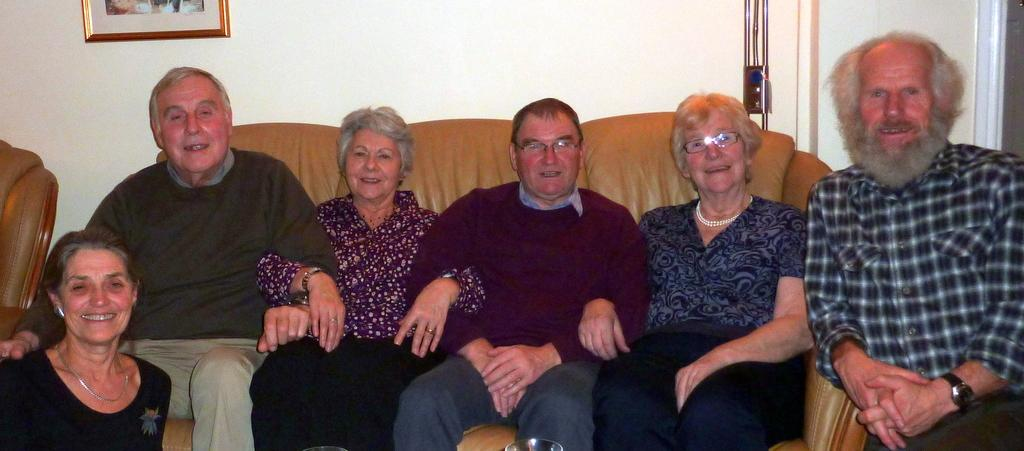Who is present in the image? There are old women and men in the image. What are they doing in the image? They are sitting on a sofa. What is behind them in the image? There is a wall behind them. What can be seen on the wall in the image? There is a photograph on the left side of the wall. What architectural feature is present on the left side of the wall? There is a door on the left side of the wall. What sound does the pig make in the image? There is no pig present in the image, so it is not possible to determine the sound it might make. 